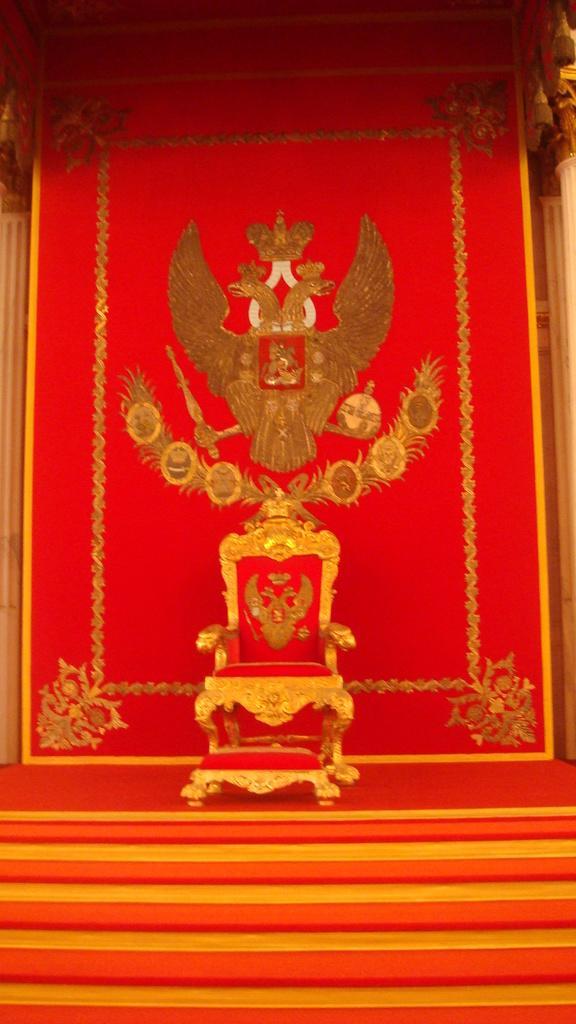Please provide a concise description of this image. In the middle of the picture, we see a chair in red color and behind that, we see a red color board on which statues of birds are placed. At the top of the picture, we see the curtains and at the bottom of the picture, we see staircases. 